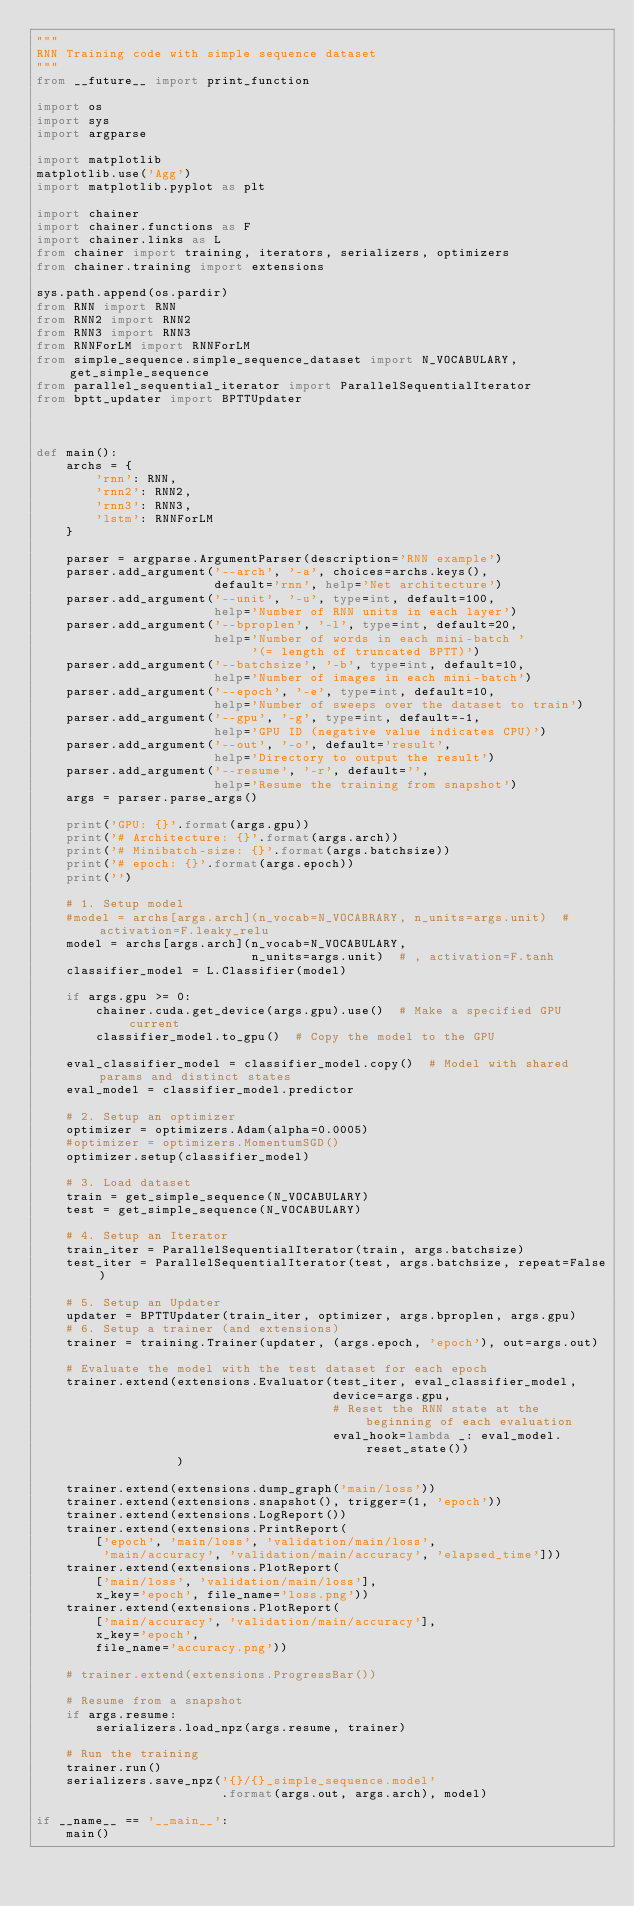Convert code to text. <code><loc_0><loc_0><loc_500><loc_500><_Python_>"""
RNN Training code with simple sequence dataset
"""
from __future__ import print_function

import os
import sys
import argparse

import matplotlib
matplotlib.use('Agg')
import matplotlib.pyplot as plt

import chainer
import chainer.functions as F
import chainer.links as L
from chainer import training, iterators, serializers, optimizers
from chainer.training import extensions

sys.path.append(os.pardir)
from RNN import RNN
from RNN2 import RNN2
from RNN3 import RNN3
from RNNForLM import RNNForLM
from simple_sequence.simple_sequence_dataset import N_VOCABULARY, get_simple_sequence
from parallel_sequential_iterator import ParallelSequentialIterator
from bptt_updater import BPTTUpdater



def main():
    archs = {
        'rnn': RNN,
        'rnn2': RNN2,
        'rnn3': RNN3,
        'lstm': RNNForLM
    }

    parser = argparse.ArgumentParser(description='RNN example')
    parser.add_argument('--arch', '-a', choices=archs.keys(),
                        default='rnn', help='Net architecture')
    parser.add_argument('--unit', '-u', type=int, default=100,
                        help='Number of RNN units in each layer')
    parser.add_argument('--bproplen', '-l', type=int, default=20,
                        help='Number of words in each mini-batch '
                             '(= length of truncated BPTT)')
    parser.add_argument('--batchsize', '-b', type=int, default=10,
                        help='Number of images in each mini-batch')
    parser.add_argument('--epoch', '-e', type=int, default=10,
                        help='Number of sweeps over the dataset to train')
    parser.add_argument('--gpu', '-g', type=int, default=-1,
                        help='GPU ID (negative value indicates CPU)')
    parser.add_argument('--out', '-o', default='result',
                        help='Directory to output the result')
    parser.add_argument('--resume', '-r', default='',
                        help='Resume the training from snapshot')
    args = parser.parse_args()

    print('GPU: {}'.format(args.gpu))
    print('# Architecture: {}'.format(args.arch))
    print('# Minibatch-size: {}'.format(args.batchsize))
    print('# epoch: {}'.format(args.epoch))
    print('')

    # 1. Setup model
    #model = archs[args.arch](n_vocab=N_VOCABRARY, n_units=args.unit)  # activation=F.leaky_relu
    model = archs[args.arch](n_vocab=N_VOCABULARY,
                             n_units=args.unit)  # , activation=F.tanh
    classifier_model = L.Classifier(model)

    if args.gpu >= 0:
        chainer.cuda.get_device(args.gpu).use()  # Make a specified GPU current
        classifier_model.to_gpu()  # Copy the model to the GPU

    eval_classifier_model = classifier_model.copy()  # Model with shared params and distinct states
    eval_model = classifier_model.predictor

    # 2. Setup an optimizer
    optimizer = optimizers.Adam(alpha=0.0005)
    #optimizer = optimizers.MomentumSGD()
    optimizer.setup(classifier_model)

    # 3. Load dataset
    train = get_simple_sequence(N_VOCABULARY)
    test = get_simple_sequence(N_VOCABULARY)

    # 4. Setup an Iterator
    train_iter = ParallelSequentialIterator(train, args.batchsize)
    test_iter = ParallelSequentialIterator(test, args.batchsize, repeat=False)

    # 5. Setup an Updater
    updater = BPTTUpdater(train_iter, optimizer, args.bproplen, args.gpu)
    # 6. Setup a trainer (and extensions)
    trainer = training.Trainer(updater, (args.epoch, 'epoch'), out=args.out)

    # Evaluate the model with the test dataset for each epoch
    trainer.extend(extensions.Evaluator(test_iter, eval_classifier_model,
                                        device=args.gpu,
                                        # Reset the RNN state at the beginning of each evaluation
                                        eval_hook=lambda _: eval_model.reset_state())
                   )

    trainer.extend(extensions.dump_graph('main/loss'))
    trainer.extend(extensions.snapshot(), trigger=(1, 'epoch'))
    trainer.extend(extensions.LogReport())
    trainer.extend(extensions.PrintReport(
        ['epoch', 'main/loss', 'validation/main/loss',
         'main/accuracy', 'validation/main/accuracy', 'elapsed_time']))
    trainer.extend(extensions.PlotReport(
        ['main/loss', 'validation/main/loss'],
        x_key='epoch', file_name='loss.png'))
    trainer.extend(extensions.PlotReport(
        ['main/accuracy', 'validation/main/accuracy'],
        x_key='epoch',
        file_name='accuracy.png'))

    # trainer.extend(extensions.ProgressBar())

    # Resume from a snapshot
    if args.resume:
        serializers.load_npz(args.resume, trainer)

    # Run the training
    trainer.run()
    serializers.save_npz('{}/{}_simple_sequence.model'
                         .format(args.out, args.arch), model)

if __name__ == '__main__':
    main()


</code> 